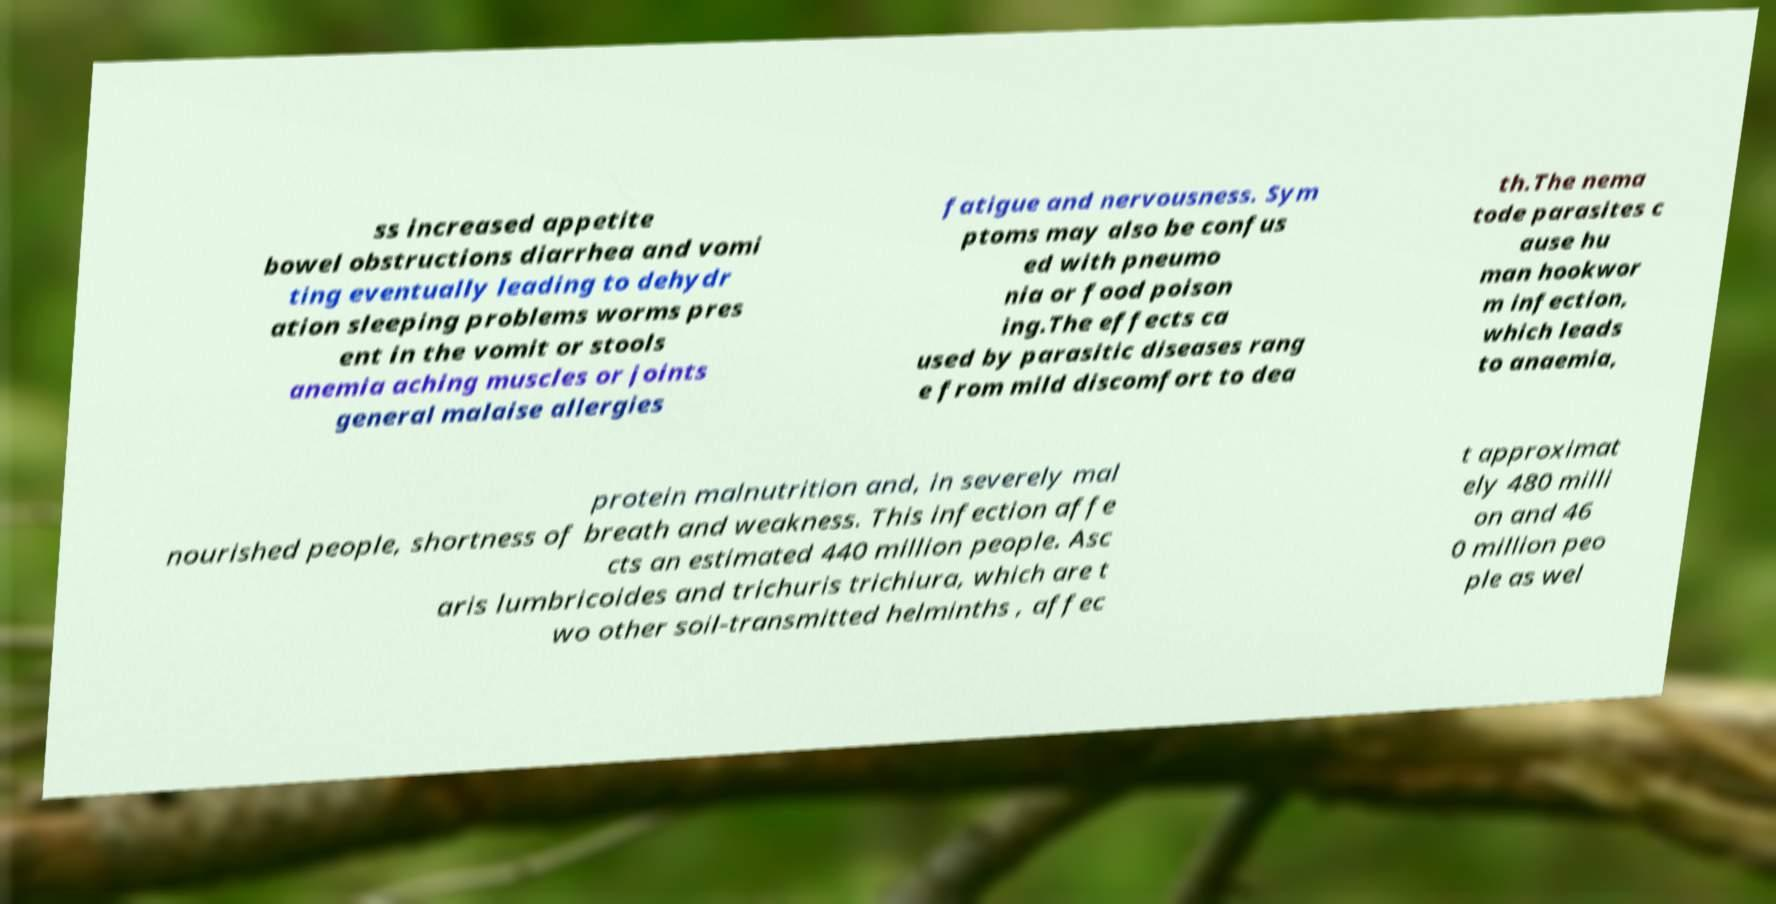For documentation purposes, I need the text within this image transcribed. Could you provide that? ss increased appetite bowel obstructions diarrhea and vomi ting eventually leading to dehydr ation sleeping problems worms pres ent in the vomit or stools anemia aching muscles or joints general malaise allergies fatigue and nervousness. Sym ptoms may also be confus ed with pneumo nia or food poison ing.The effects ca used by parasitic diseases rang e from mild discomfort to dea th.The nema tode parasites c ause hu man hookwor m infection, which leads to anaemia, protein malnutrition and, in severely mal nourished people, shortness of breath and weakness. This infection affe cts an estimated 440 million people. Asc aris lumbricoides and trichuris trichiura, which are t wo other soil-transmitted helminths , affec t approximat ely 480 milli on and 46 0 million peo ple as wel 